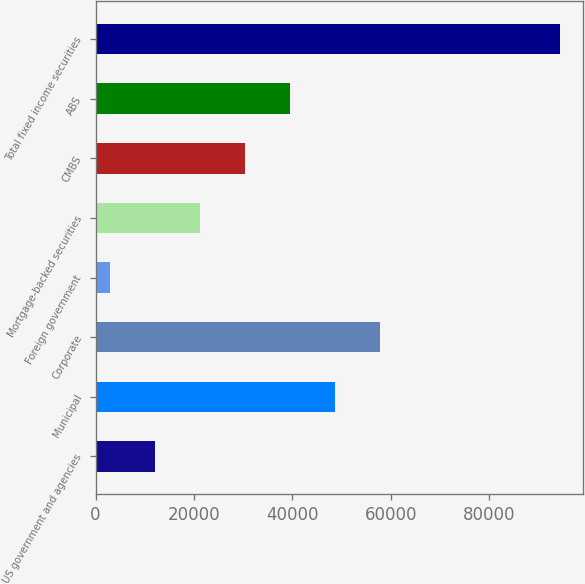Convert chart. <chart><loc_0><loc_0><loc_500><loc_500><bar_chart><fcel>US government and agencies<fcel>Municipal<fcel>Corporate<fcel>Foreign government<fcel>Mortgage-backed securities<fcel>CMBS<fcel>ABS<fcel>Total fixed income securities<nl><fcel>12087.5<fcel>48693.5<fcel>57845<fcel>2936<fcel>21239<fcel>30390.5<fcel>39542<fcel>94451<nl></chart> 